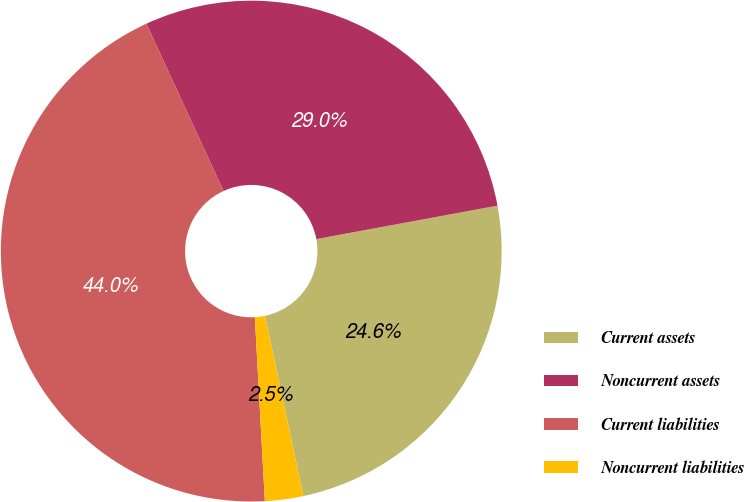Convert chart. <chart><loc_0><loc_0><loc_500><loc_500><pie_chart><fcel>Current assets<fcel>Noncurrent assets<fcel>Current liabilities<fcel>Noncurrent liabilities<nl><fcel>24.57%<fcel>28.97%<fcel>43.99%<fcel>2.47%<nl></chart> 